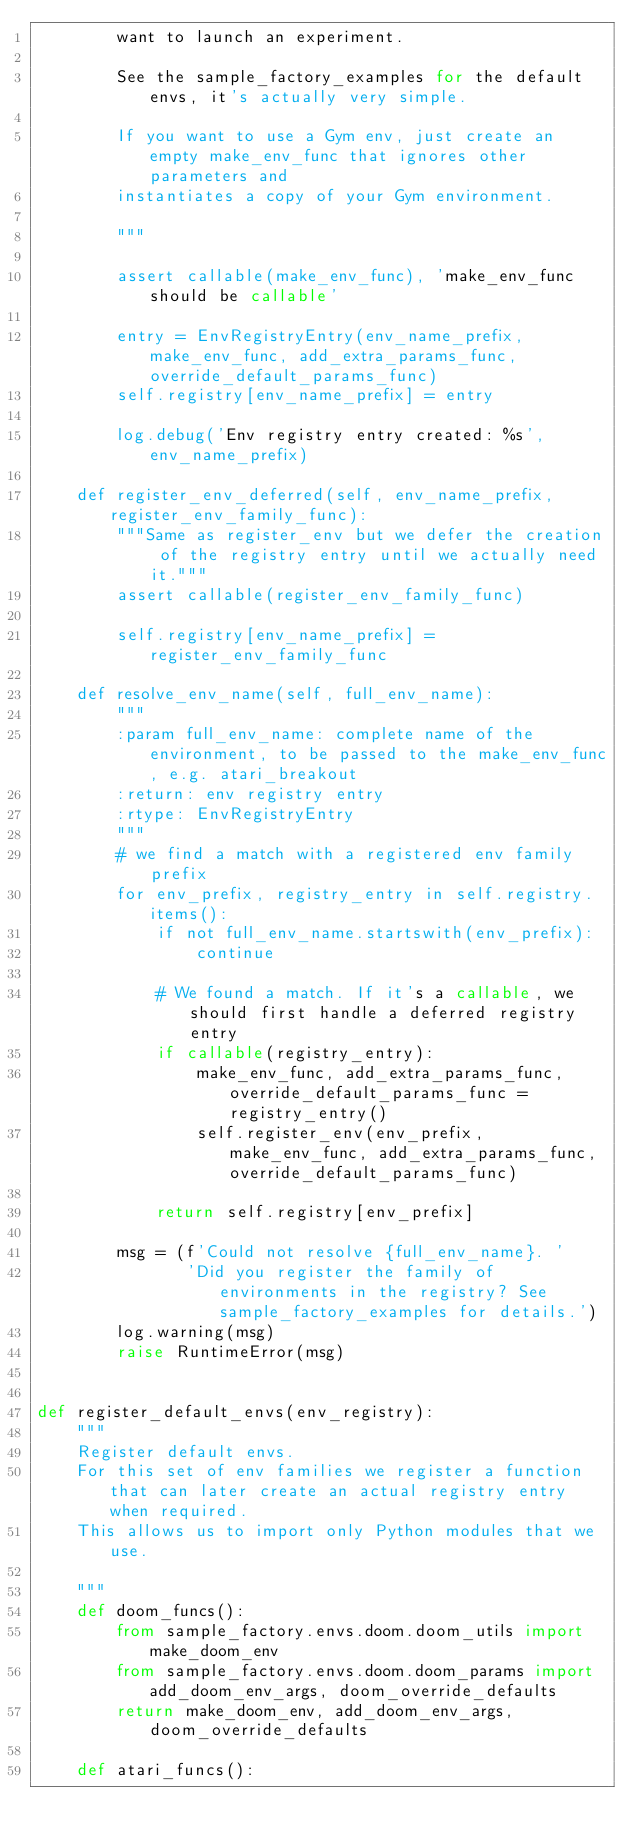Convert code to text. <code><loc_0><loc_0><loc_500><loc_500><_Python_>        want to launch an experiment.

        See the sample_factory_examples for the default envs, it's actually very simple.

        If you want to use a Gym env, just create an empty make_env_func that ignores other parameters and
        instantiates a copy of your Gym environment.

        """

        assert callable(make_env_func), 'make_env_func should be callable'

        entry = EnvRegistryEntry(env_name_prefix, make_env_func, add_extra_params_func, override_default_params_func)
        self.registry[env_name_prefix] = entry

        log.debug('Env registry entry created: %s', env_name_prefix)

    def register_env_deferred(self, env_name_prefix, register_env_family_func):
        """Same as register_env but we defer the creation of the registry entry until we actually need it."""
        assert callable(register_env_family_func)

        self.registry[env_name_prefix] = register_env_family_func
        
    def resolve_env_name(self, full_env_name):
        """
        :param full_env_name: complete name of the environment, to be passed to the make_env_func, e.g. atari_breakout
        :return: env registry entry
        :rtype: EnvRegistryEntry
        """
        # we find a match with a registered env family prefix
        for env_prefix, registry_entry in self.registry.items():
            if not full_env_name.startswith(env_prefix):
                continue

            # We found a match. If it's a callable, we should first handle a deferred registry entry
            if callable(registry_entry):
                make_env_func, add_extra_params_func, override_default_params_func = registry_entry()
                self.register_env(env_prefix, make_env_func, add_extra_params_func, override_default_params_func)

            return self.registry[env_prefix]

        msg = (f'Could not resolve {full_env_name}. '
               'Did you register the family of environments in the registry? See sample_factory_examples for details.')
        log.warning(msg)
        raise RuntimeError(msg)


def register_default_envs(env_registry):
    """
    Register default envs.
    For this set of env families we register a function that can later create an actual registry entry when required.
    This allows us to import only Python modules that we use.

    """
    def doom_funcs():
        from sample_factory.envs.doom.doom_utils import make_doom_env
        from sample_factory.envs.doom.doom_params import add_doom_env_args, doom_override_defaults
        return make_doom_env, add_doom_env_args, doom_override_defaults

    def atari_funcs():</code> 